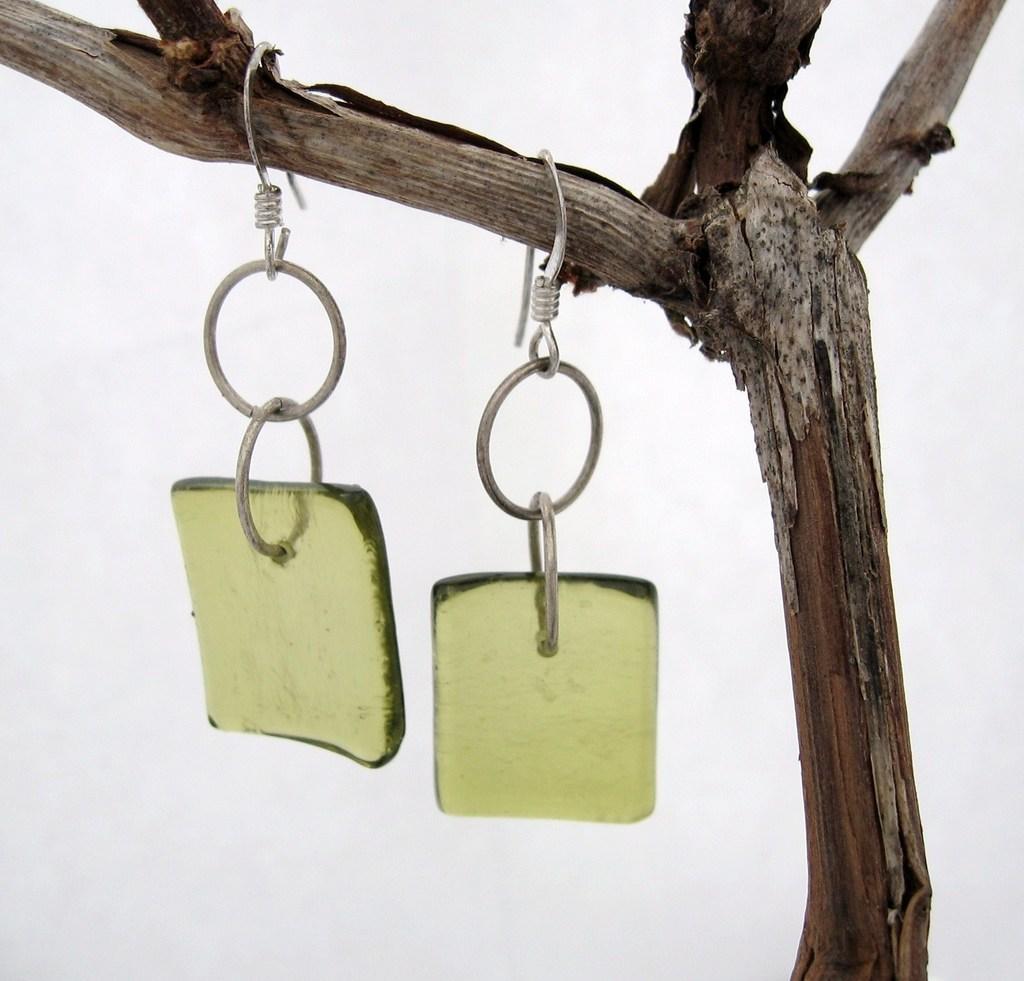What type of accessory is featured in the image? There is a pair of earrings in the image. How are the earrings displayed in the image? The earrings are hanging from a stick. What color is the background of the image? The background of the image is white. How many eggs are sitting on the chairs in the image? There are no eggs or chairs present in the image. Is there a spy observing the earrings in the image? There is no indication of a spy or any person observing the earrings in the image. 